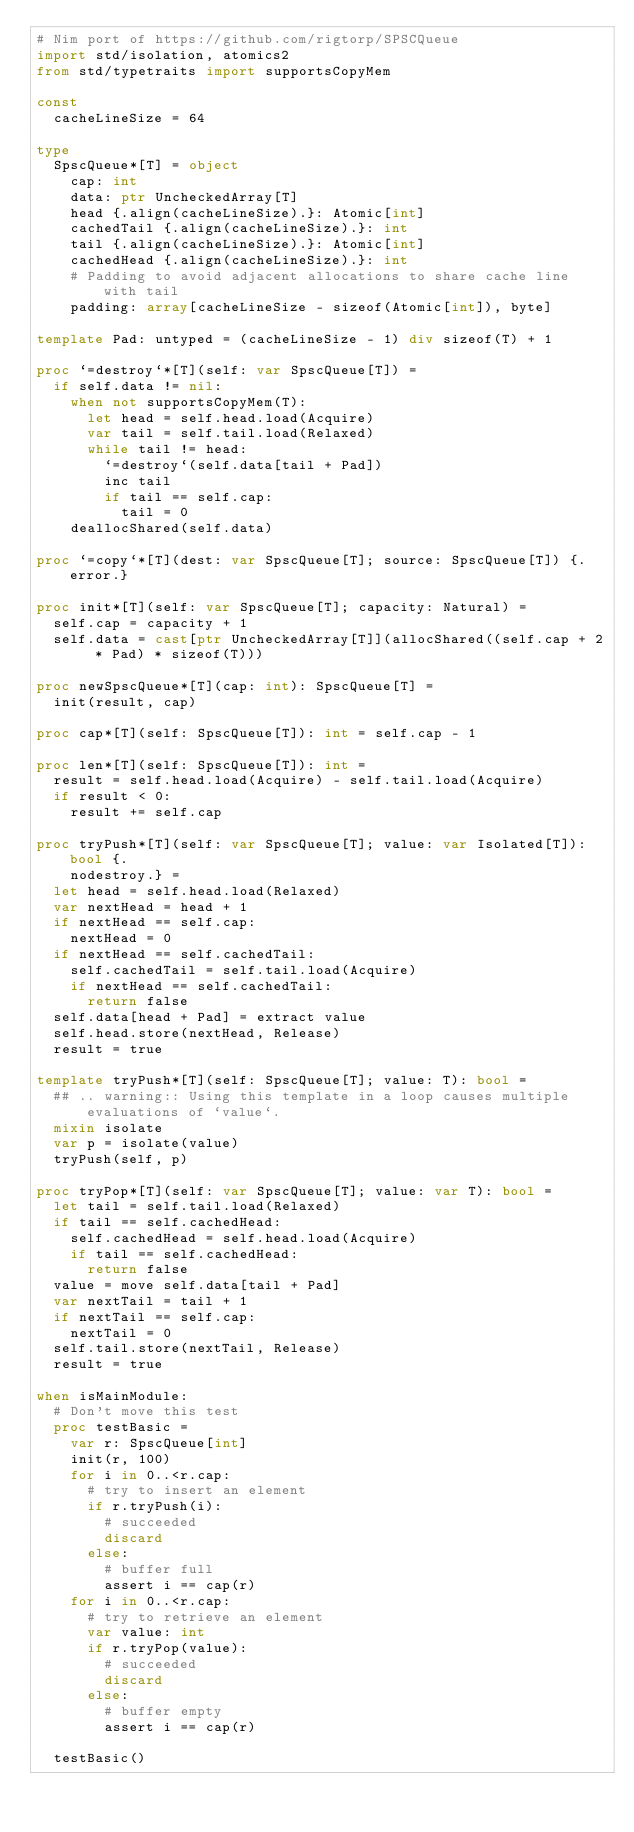<code> <loc_0><loc_0><loc_500><loc_500><_Nim_># Nim port of https://github.com/rigtorp/SPSCQueue
import std/isolation, atomics2
from std/typetraits import supportsCopyMem

const
  cacheLineSize = 64

type
  SpscQueue*[T] = object
    cap: int
    data: ptr UncheckedArray[T]
    head {.align(cacheLineSize).}: Atomic[int]
    cachedTail {.align(cacheLineSize).}: int
    tail {.align(cacheLineSize).}: Atomic[int]
    cachedHead {.align(cacheLineSize).}: int
    # Padding to avoid adjacent allocations to share cache line with tail
    padding: array[cacheLineSize - sizeof(Atomic[int]), byte]

template Pad: untyped = (cacheLineSize - 1) div sizeof(T) + 1

proc `=destroy`*[T](self: var SpscQueue[T]) =
  if self.data != nil:
    when not supportsCopyMem(T):
      let head = self.head.load(Acquire)
      var tail = self.tail.load(Relaxed)
      while tail != head:
        `=destroy`(self.data[tail + Pad])
        inc tail
        if tail == self.cap:
          tail = 0
    deallocShared(self.data)

proc `=copy`*[T](dest: var SpscQueue[T]; source: SpscQueue[T]) {.error.}

proc init*[T](self: var SpscQueue[T]; capacity: Natural) =
  self.cap = capacity + 1
  self.data = cast[ptr UncheckedArray[T]](allocShared((self.cap + 2 * Pad) * sizeof(T)))

proc newSpscQueue*[T](cap: int): SpscQueue[T] =
  init(result, cap)

proc cap*[T](self: SpscQueue[T]): int = self.cap - 1

proc len*[T](self: SpscQueue[T]): int =
  result = self.head.load(Acquire) - self.tail.load(Acquire)
  if result < 0:
    result += self.cap

proc tryPush*[T](self: var SpscQueue[T]; value: var Isolated[T]): bool {.
    nodestroy.} =
  let head = self.head.load(Relaxed)
  var nextHead = head + 1
  if nextHead == self.cap:
    nextHead = 0
  if nextHead == self.cachedTail:
    self.cachedTail = self.tail.load(Acquire)
    if nextHead == self.cachedTail:
      return false
  self.data[head + Pad] = extract value
  self.head.store(nextHead, Release)
  result = true

template tryPush*[T](self: SpscQueue[T]; value: T): bool =
  ## .. warning:: Using this template in a loop causes multiple evaluations of `value`.
  mixin isolate
  var p = isolate(value)
  tryPush(self, p)

proc tryPop*[T](self: var SpscQueue[T]; value: var T): bool =
  let tail = self.tail.load(Relaxed)
  if tail == self.cachedHead:
    self.cachedHead = self.head.load(Acquire)
    if tail == self.cachedHead:
      return false
  value = move self.data[tail + Pad]
  var nextTail = tail + 1
  if nextTail == self.cap:
    nextTail = 0
  self.tail.store(nextTail, Release)
  result = true

when isMainModule:
  # Don't move this test
  proc testBasic =
    var r: SpscQueue[int]
    init(r, 100)
    for i in 0..<r.cap:
      # try to insert an element
      if r.tryPush(i):
        # succeeded
        discard
      else:
        # buffer full
        assert i == cap(r)
    for i in 0..<r.cap:
      # try to retrieve an element
      var value: int
      if r.tryPop(value):
        # succeeded
        discard
      else:
        # buffer empty
        assert i == cap(r)

  testBasic()
</code> 